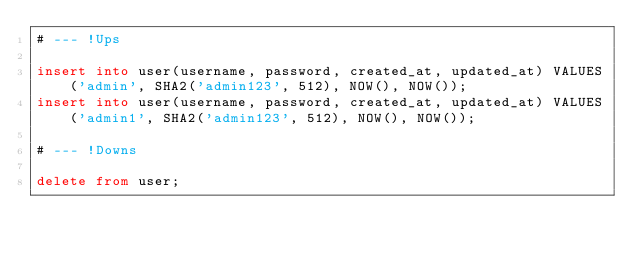Convert code to text. <code><loc_0><loc_0><loc_500><loc_500><_SQL_># --- !Ups

insert into user(username, password, created_at, updated_at) VALUES('admin', SHA2('admin123', 512), NOW(), NOW());
insert into user(username, password, created_at, updated_at) VALUES('admin1', SHA2('admin123', 512), NOW(), NOW());

# --- !Downs

delete from user;
</code> 